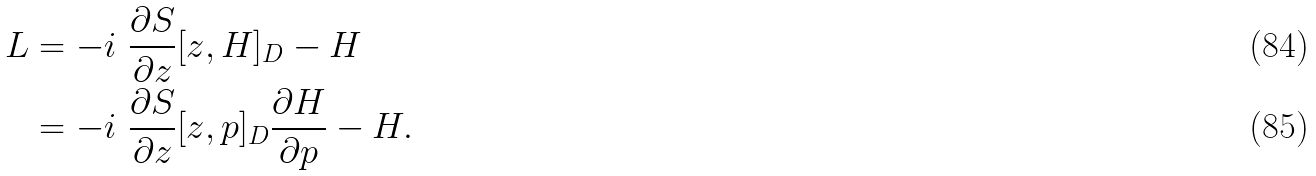Convert formula to latex. <formula><loc_0><loc_0><loc_500><loc_500>L & = - i \ \frac { \partial S } { \partial z } [ z , H ] _ { D } - H \\ & = - i \ \frac { \partial S } { \partial z } [ z , p ] _ { D } \frac { \partial H } { \partial p } - H .</formula> 